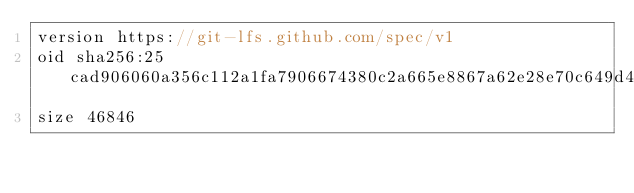Convert code to text. <code><loc_0><loc_0><loc_500><loc_500><_Cuda_>version https://git-lfs.github.com/spec/v1
oid sha256:25cad906060a356c112a1fa7906674380c2a665e8867a62e28e70c649d44a38b
size 46846
</code> 